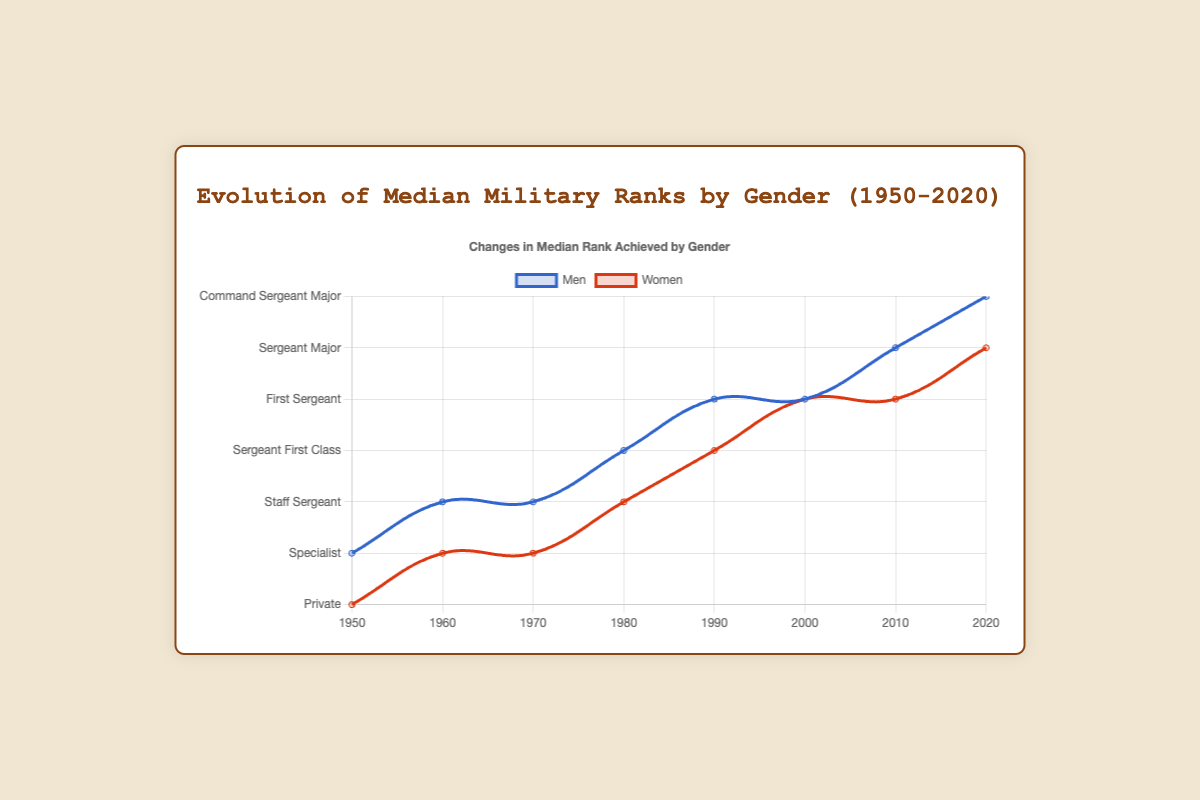What is the highest median rank achieved by men between 1950 and 2020? The highest median rank achieved by men, as depicted by the blue line in the figure, is "Command Sergeant Major" in 2020.
Answer: Command Sergeant Major How is the median rank of women in 2020 compared to 1950? In 1950, the median rank for women was "Private", represented in red at the lowest point on the y-axis. By 2020, it increased to "Sergeant Major", represented near the top of the y-axis in red.
Answer: It increased from Private to Sergeant Major Which year shows the smallest gap between the median ranks of men and women? In 2000, the median rank for men was "First Sergeant" (4 on the y-axis) and for women was also "Master Sergeant" (4 on the y-axis). They are equal, indicating the smallest gap.
Answer: 2000 From 1960 to 1970, what was the change in the median rank for both men and women? For men, the median rank stayed as "Staff Sergeant" (2 on the y-axis), and for women, it slightly increased from "Specialist" (1 on the y-axis) to "Corporal" (1 on the y-axis).
Answer: Men: No change, Women: Increased slightly In which decade did women achieve a rank equivalent to the median rank of men in the 1970s? In the 1970s, the median men's rank was "Staff Sergeant" (2 on the y-axis). Women reached this rank in the 1980s (3 on y-axis).
Answer: 1980s What is the general trend of median ranks for women compared to men from 1950 to 2020? For both genders, the rank generally increased over time; however, women started at a much lower rank and gradually closed the gap with men.
Answer: Increasing for both, with women closing the gap How much did the median rank for men change from 1950 to 1980? In 1950, the median rank for men was "Sergeant" (1 on the y-axis), and by 1980, it was "Sergeant First Class" (3 on the y-axis). The change involved increasing by two ranks.
Answer: Increased by two ranks What visual attribute helps compare the median ranks of men and women? The color differentiation—blue for men and red for women—helps visually separate and compare their median ranks over time.
Answer: Color differentiation Which year shows the same median rank for both genders, and what is the rank? In 2000, both genders had the median rank of "Master Sergeant" (4 on the y-axis in both blue and red lines).
Answer: 2000, Master Sergeant How did the median rank for women change in the 1990s compared to the 2000s? In the 1990s, the median rank for women was "Sergeant First Class" (3 on the y-axis in red), and in the 2000s, it was "Master Sergeant" (4 on the y-axis in red), indicating a one-rank increase.
Answer: Increased by one rank 